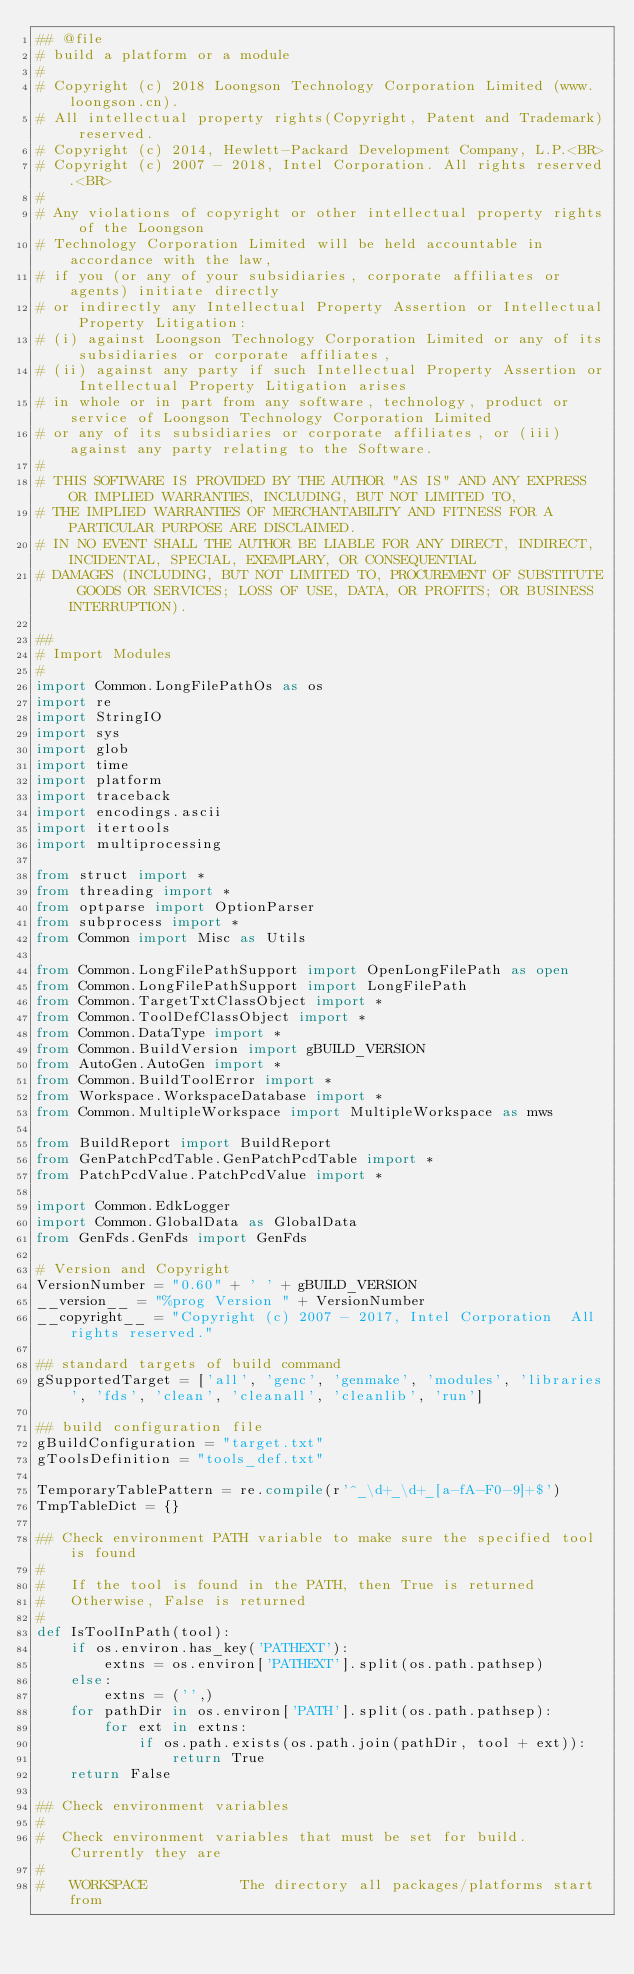<code> <loc_0><loc_0><loc_500><loc_500><_Python_>## @file
# build a platform or a module
#
# Copyright (c) 2018 Loongson Technology Corporation Limited (www.loongson.cn).
# All intellectual property rights(Copyright, Patent and Trademark) reserved.
# Copyright (c) 2014, Hewlett-Packard Development Company, L.P.<BR>
# Copyright (c) 2007 - 2018, Intel Corporation. All rights reserved.<BR>
#
# Any violations of copyright or other intellectual property rights of the Loongson
# Technology Corporation Limited will be held accountable in accordance with the law,
# if you (or any of your subsidiaries, corporate affiliates or agents) initiate directly
# or indirectly any Intellectual Property Assertion or Intellectual Property Litigation:
# (i) against Loongson Technology Corporation Limited or any of its subsidiaries or corporate affiliates,
# (ii) against any party if such Intellectual Property Assertion or Intellectual Property Litigation arises
# in whole or in part from any software, technology, product or service of Loongson Technology Corporation Limited
# or any of its subsidiaries or corporate affiliates, or (iii) against any party relating to the Software.
#
# THIS SOFTWARE IS PROVIDED BY THE AUTHOR "AS IS" AND ANY EXPRESS OR IMPLIED WARRANTIES, INCLUDING, BUT NOT LIMITED TO,
# THE IMPLIED WARRANTIES OF MERCHANTABILITY AND FITNESS FOR A PARTICULAR PURPOSE ARE DISCLAIMED.
# IN NO EVENT SHALL THE AUTHOR BE LIABLE FOR ANY DIRECT, INDIRECT, INCIDENTAL, SPECIAL, EXEMPLARY, OR CONSEQUENTIAL
# DAMAGES (INCLUDING, BUT NOT LIMITED TO, PROCUREMENT OF SUBSTITUTE GOODS OR SERVICES; LOSS OF USE, DATA, OR PROFITS; OR BUSINESS INTERRUPTION).

##
# Import Modules
#
import Common.LongFilePathOs as os
import re
import StringIO
import sys
import glob
import time
import platform
import traceback
import encodings.ascii
import itertools
import multiprocessing

from struct import *
from threading import *
from optparse import OptionParser
from subprocess import *
from Common import Misc as Utils

from Common.LongFilePathSupport import OpenLongFilePath as open
from Common.LongFilePathSupport import LongFilePath
from Common.TargetTxtClassObject import *
from Common.ToolDefClassObject import *
from Common.DataType import *
from Common.BuildVersion import gBUILD_VERSION
from AutoGen.AutoGen import *
from Common.BuildToolError import *
from Workspace.WorkspaceDatabase import *
from Common.MultipleWorkspace import MultipleWorkspace as mws

from BuildReport import BuildReport
from GenPatchPcdTable.GenPatchPcdTable import *
from PatchPcdValue.PatchPcdValue import *

import Common.EdkLogger
import Common.GlobalData as GlobalData
from GenFds.GenFds import GenFds

# Version and Copyright
VersionNumber = "0.60" + ' ' + gBUILD_VERSION
__version__ = "%prog Version " + VersionNumber
__copyright__ = "Copyright (c) 2007 - 2017, Intel Corporation  All rights reserved."

## standard targets of build command
gSupportedTarget = ['all', 'genc', 'genmake', 'modules', 'libraries', 'fds', 'clean', 'cleanall', 'cleanlib', 'run']

## build configuration file
gBuildConfiguration = "target.txt"
gToolsDefinition = "tools_def.txt"

TemporaryTablePattern = re.compile(r'^_\d+_\d+_[a-fA-F0-9]+$')
TmpTableDict = {}

## Check environment PATH variable to make sure the specified tool is found
#
#   If the tool is found in the PATH, then True is returned
#   Otherwise, False is returned
#
def IsToolInPath(tool):
    if os.environ.has_key('PATHEXT'):
        extns = os.environ['PATHEXT'].split(os.path.pathsep)
    else:
        extns = ('',)
    for pathDir in os.environ['PATH'].split(os.path.pathsep):
        for ext in extns:
            if os.path.exists(os.path.join(pathDir, tool + ext)):
                return True
    return False

## Check environment variables
#
#  Check environment variables that must be set for build. Currently they are
#
#   WORKSPACE           The directory all packages/platforms start from</code> 